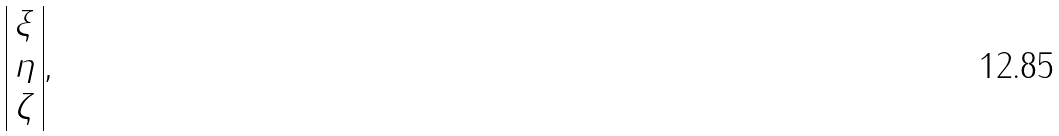Convert formula to latex. <formula><loc_0><loc_0><loc_500><loc_500>\begin{array} { | c | } \xi \\ \eta \\ \zeta \\ \end{array} ,</formula> 